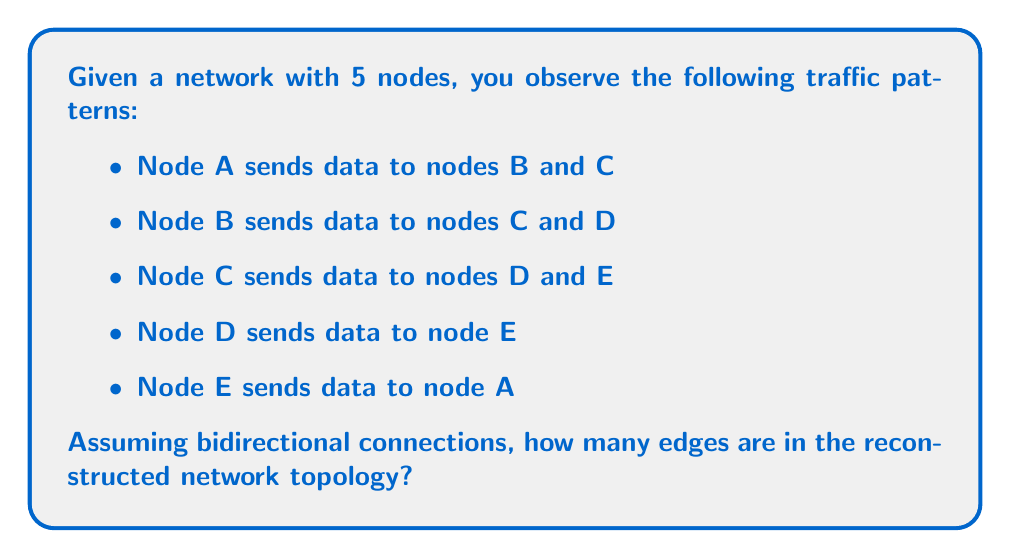Show me your answer to this math problem. To solve this problem, we'll follow these steps:

1. Identify unique connections from the observed traffic patterns:
   A → B, A → C
   B → C, B → D
   C → D, C → E
   D → E
   E → A

2. Convert unidirectional connections to bidirectional:
   A ↔ B, A ↔ C
   B ↔ C, B ↔ D
   C ↔ D, C ↔ E
   D ↔ E
   E ↔ A

3. Count unique bidirectional connections:
   A ↔ B
   A ↔ C
   A ↔ E
   B ↔ C
   B ↔ D
   C ↔ D
   C ↔ E
   D ↔ E

4. Calculate the total number of edges:
   $$\text{Number of edges} = 8$$

Each bidirectional connection represents one edge in the network topology.
Answer: 8 